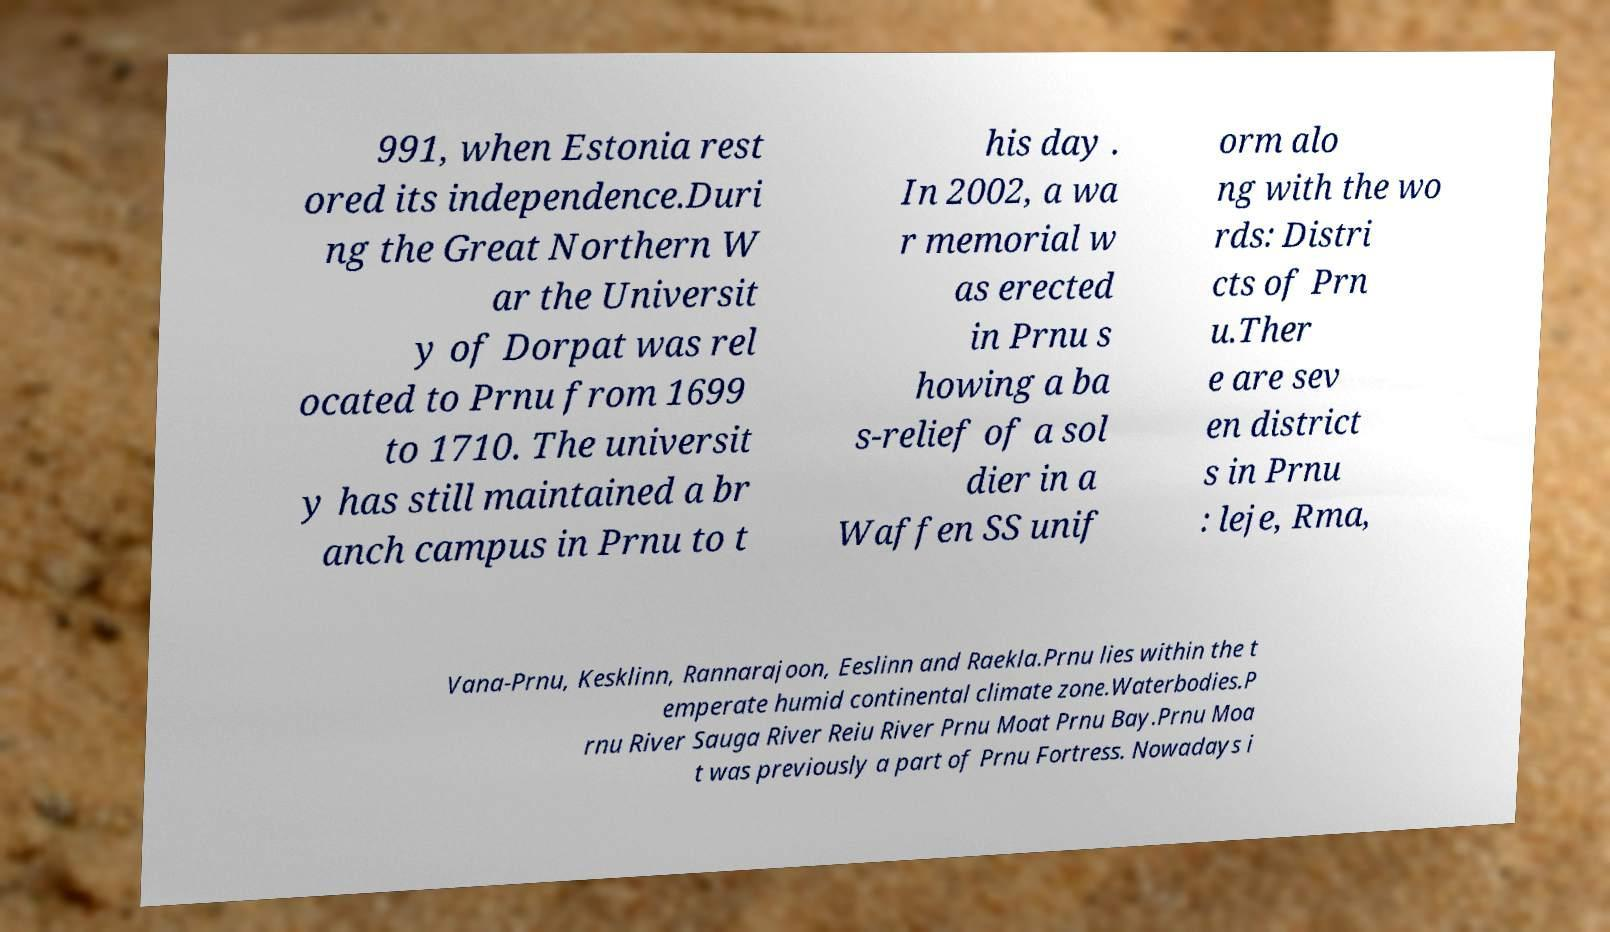For documentation purposes, I need the text within this image transcribed. Could you provide that? 991, when Estonia rest ored its independence.Duri ng the Great Northern W ar the Universit y of Dorpat was rel ocated to Prnu from 1699 to 1710. The universit y has still maintained a br anch campus in Prnu to t his day . In 2002, a wa r memorial w as erected in Prnu s howing a ba s-relief of a sol dier in a Waffen SS unif orm alo ng with the wo rds: Distri cts of Prn u.Ther e are sev en district s in Prnu : leje, Rma, Vana-Prnu, Kesklinn, Rannarajoon, Eeslinn and Raekla.Prnu lies within the t emperate humid continental climate zone.Waterbodies.P rnu River Sauga River Reiu River Prnu Moat Prnu Bay.Prnu Moa t was previously a part of Prnu Fortress. Nowadays i 